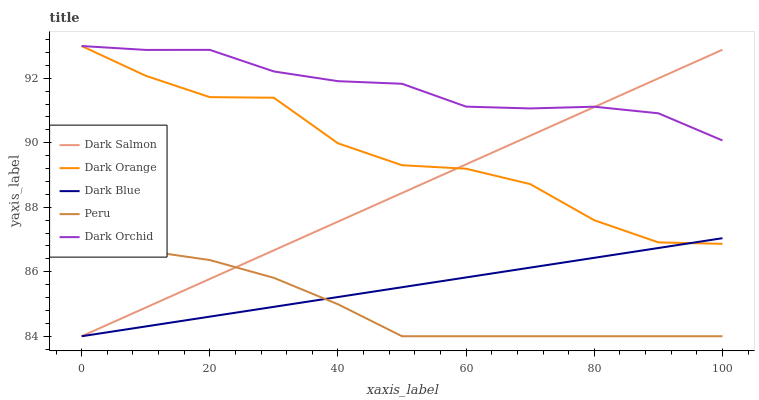Does Peru have the minimum area under the curve?
Answer yes or no. Yes. Does Dark Orchid have the maximum area under the curve?
Answer yes or no. Yes. Does Dark Orange have the minimum area under the curve?
Answer yes or no. No. Does Dark Orange have the maximum area under the curve?
Answer yes or no. No. Is Dark Salmon the smoothest?
Answer yes or no. Yes. Is Dark Orange the roughest?
Answer yes or no. Yes. Is Dark Orange the smoothest?
Answer yes or no. No. Is Dark Salmon the roughest?
Answer yes or no. No. Does Dark Salmon have the lowest value?
Answer yes or no. Yes. Does Dark Orange have the lowest value?
Answer yes or no. No. Does Dark Orange have the highest value?
Answer yes or no. Yes. Does Dark Salmon have the highest value?
Answer yes or no. No. Is Dark Blue less than Dark Orchid?
Answer yes or no. Yes. Is Dark Orchid greater than Peru?
Answer yes or no. Yes. Does Dark Orange intersect Dark Salmon?
Answer yes or no. Yes. Is Dark Orange less than Dark Salmon?
Answer yes or no. No. Is Dark Orange greater than Dark Salmon?
Answer yes or no. No. Does Dark Blue intersect Dark Orchid?
Answer yes or no. No. 